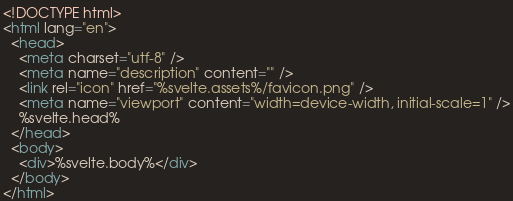<code> <loc_0><loc_0><loc_500><loc_500><_HTML_><!DOCTYPE html>
<html lang="en">
  <head>
    <meta charset="utf-8" />
    <meta name="description" content="" />
    <link rel="icon" href="%svelte.assets%/favicon.png" />
    <meta name="viewport" content="width=device-width, initial-scale=1" />
    %svelte.head%
  </head>
  <body>
    <div>%svelte.body%</div>
  </body>
</html>
</code> 